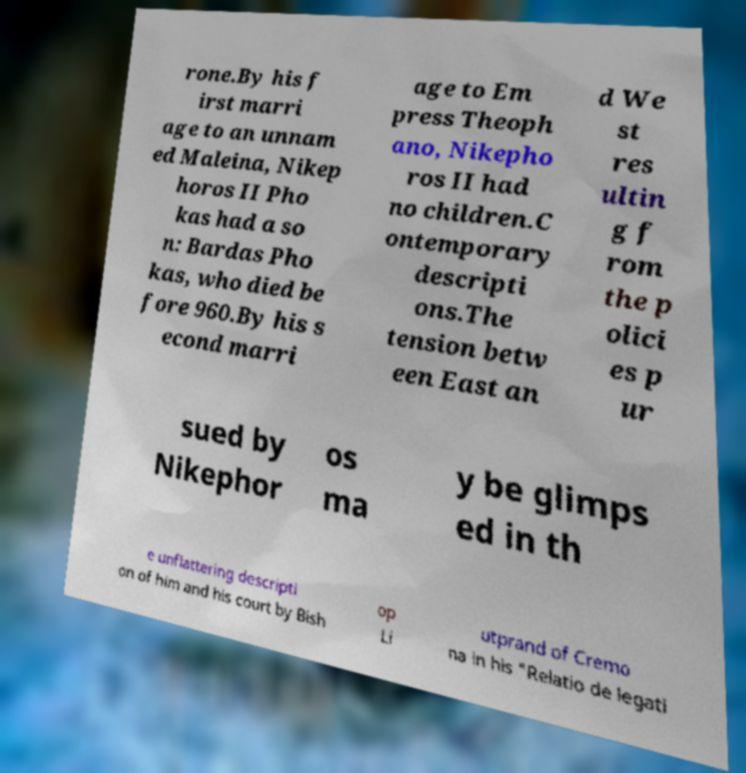Please identify and transcribe the text found in this image. rone.By his f irst marri age to an unnam ed Maleina, Nikep horos II Pho kas had a so n: Bardas Pho kas, who died be fore 960.By his s econd marri age to Em press Theoph ano, Nikepho ros II had no children.C ontemporary descripti ons.The tension betw een East an d We st res ultin g f rom the p olici es p ur sued by Nikephor os ma y be glimps ed in th e unflattering descripti on of him and his court by Bish op Li utprand of Cremo na in his "Relatio de legati 